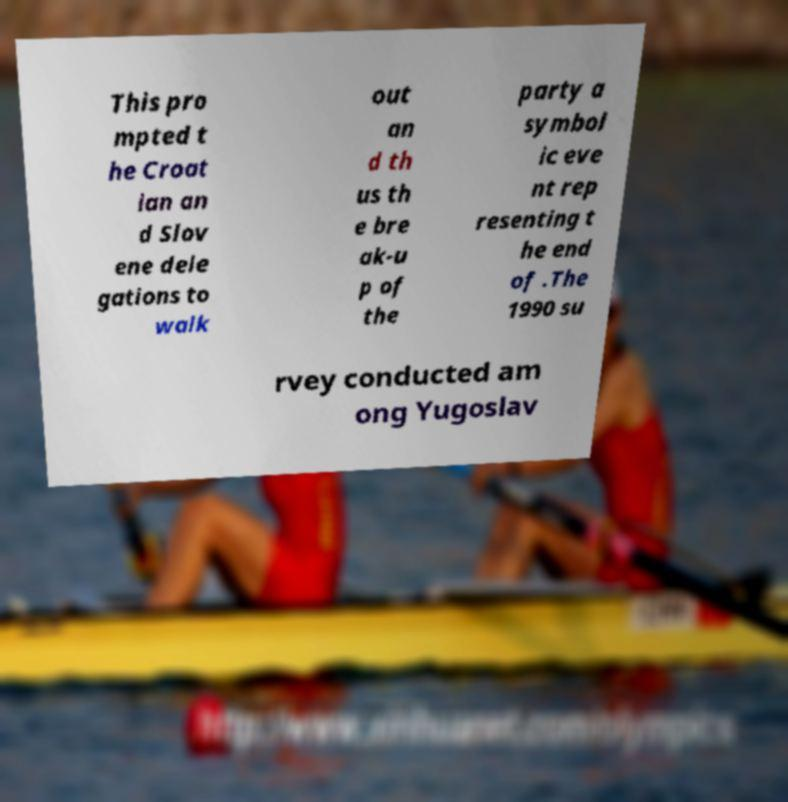Please read and relay the text visible in this image. What does it say? This pro mpted t he Croat ian an d Slov ene dele gations to walk out an d th us th e bre ak-u p of the party a symbol ic eve nt rep resenting t he end of .The 1990 su rvey conducted am ong Yugoslav 